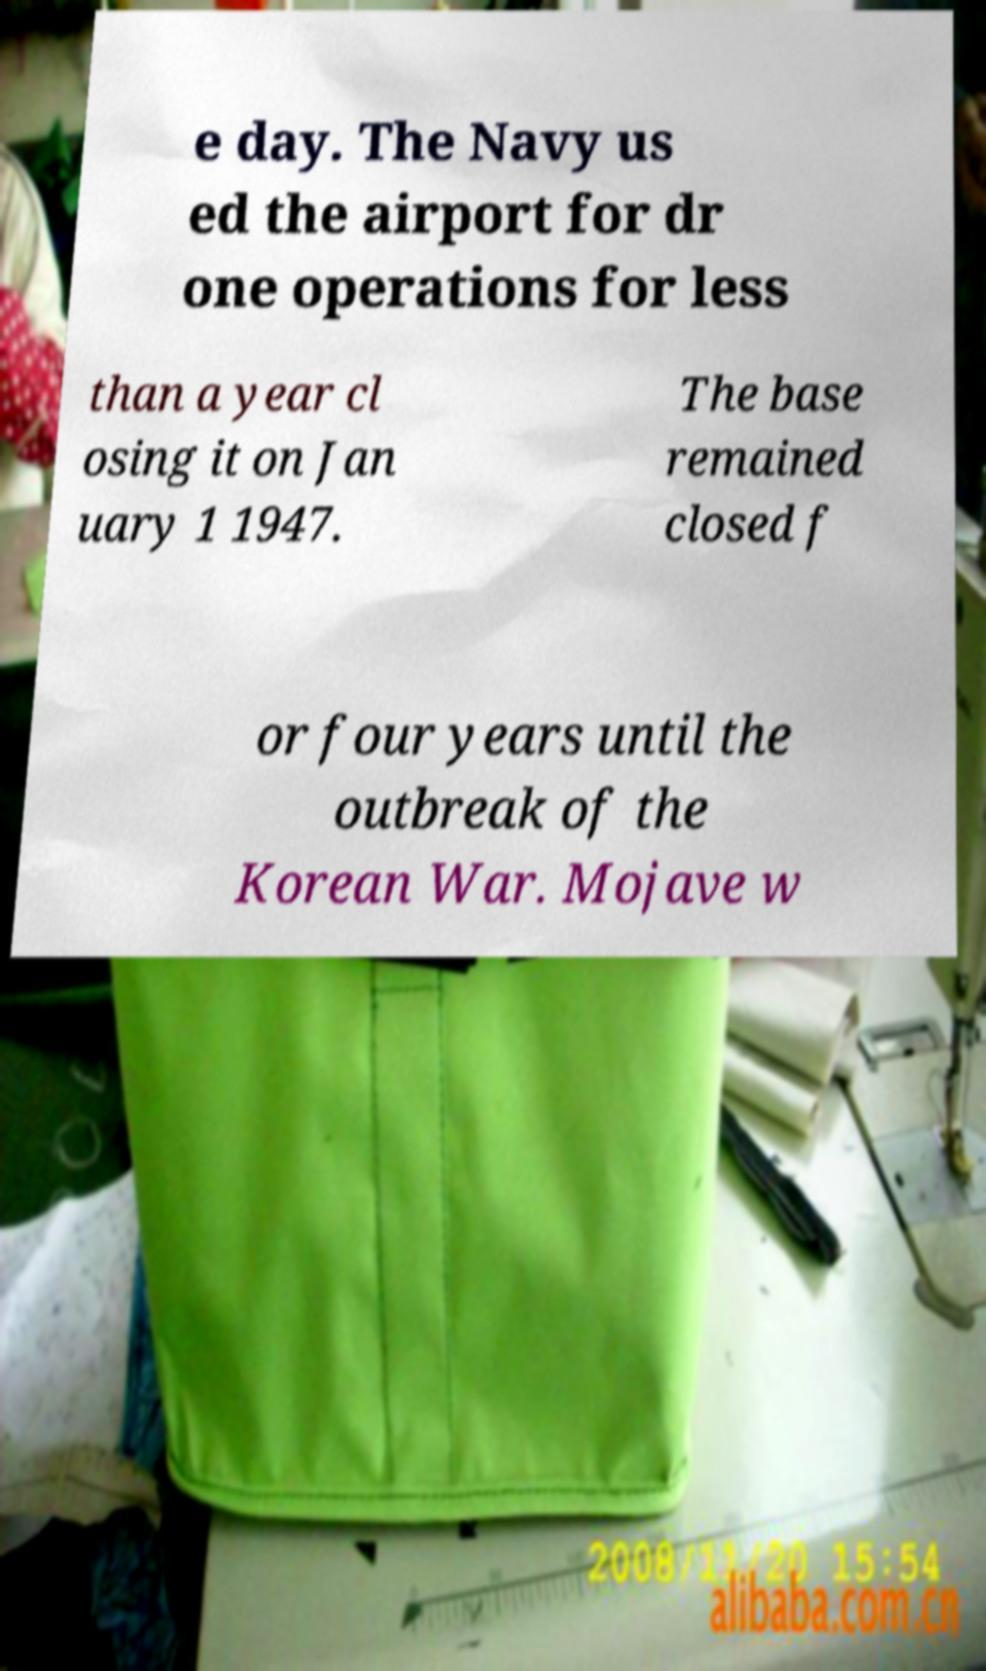Please read and relay the text visible in this image. What does it say? e day. The Navy us ed the airport for dr one operations for less than a year cl osing it on Jan uary 1 1947. The base remained closed f or four years until the outbreak of the Korean War. Mojave w 